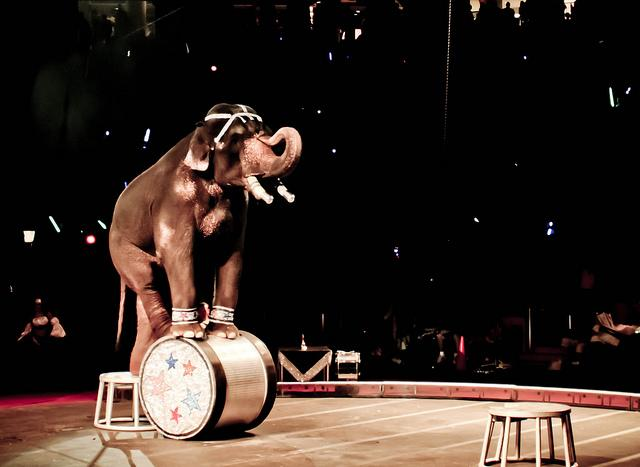Why is the elephant placing its legs on the wheel?

Choices:
A) to scratch
B) to flip
C) to kick
D) to mount to mount 